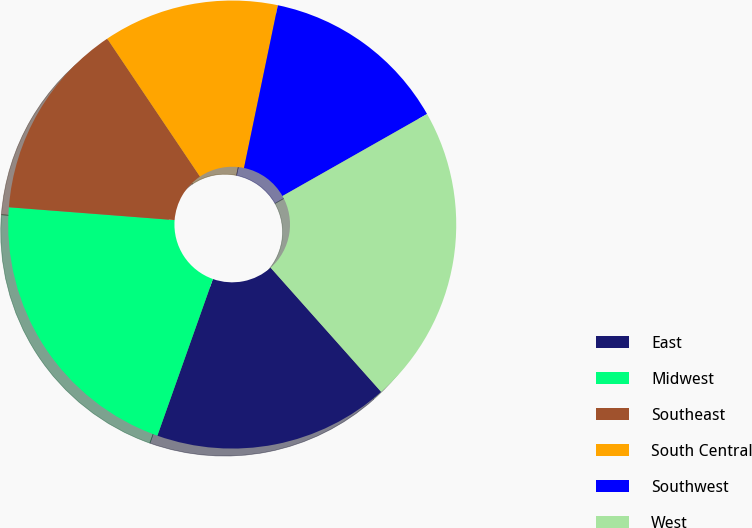Convert chart. <chart><loc_0><loc_0><loc_500><loc_500><pie_chart><fcel>East<fcel>Midwest<fcel>Southeast<fcel>South Central<fcel>Southwest<fcel>West<nl><fcel>17.0%<fcel>20.81%<fcel>14.35%<fcel>12.69%<fcel>13.52%<fcel>21.64%<nl></chart> 